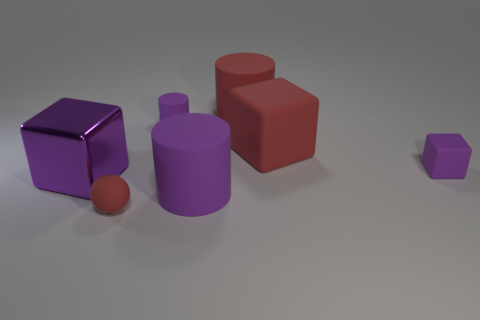Does the purple thing on the left side of the ball have the same size as the sphere?
Your response must be concise. No. There is a purple shiny thing; how many purple cubes are behind it?
Provide a succinct answer. 1. Is there a green sphere of the same size as the red rubber cylinder?
Make the answer very short. No. Do the small cube and the large metallic object have the same color?
Keep it short and to the point. Yes. The large cylinder right of the cylinder in front of the shiny thing is what color?
Your answer should be very brief. Red. What number of objects are both in front of the big purple cube and on the right side of the matte sphere?
Provide a succinct answer. 1. How many red matte objects have the same shape as the big purple metal thing?
Make the answer very short. 1. Do the tiny block and the red cube have the same material?
Your answer should be compact. Yes. The red thing that is in front of the big cube that is to the right of the small red matte sphere is what shape?
Keep it short and to the point. Sphere. How many purple shiny cubes are behind the large matte cylinder that is behind the metallic block?
Make the answer very short. 0. 